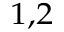<formula> <loc_0><loc_0><loc_500><loc_500>^ { 1 , 2 }</formula> 